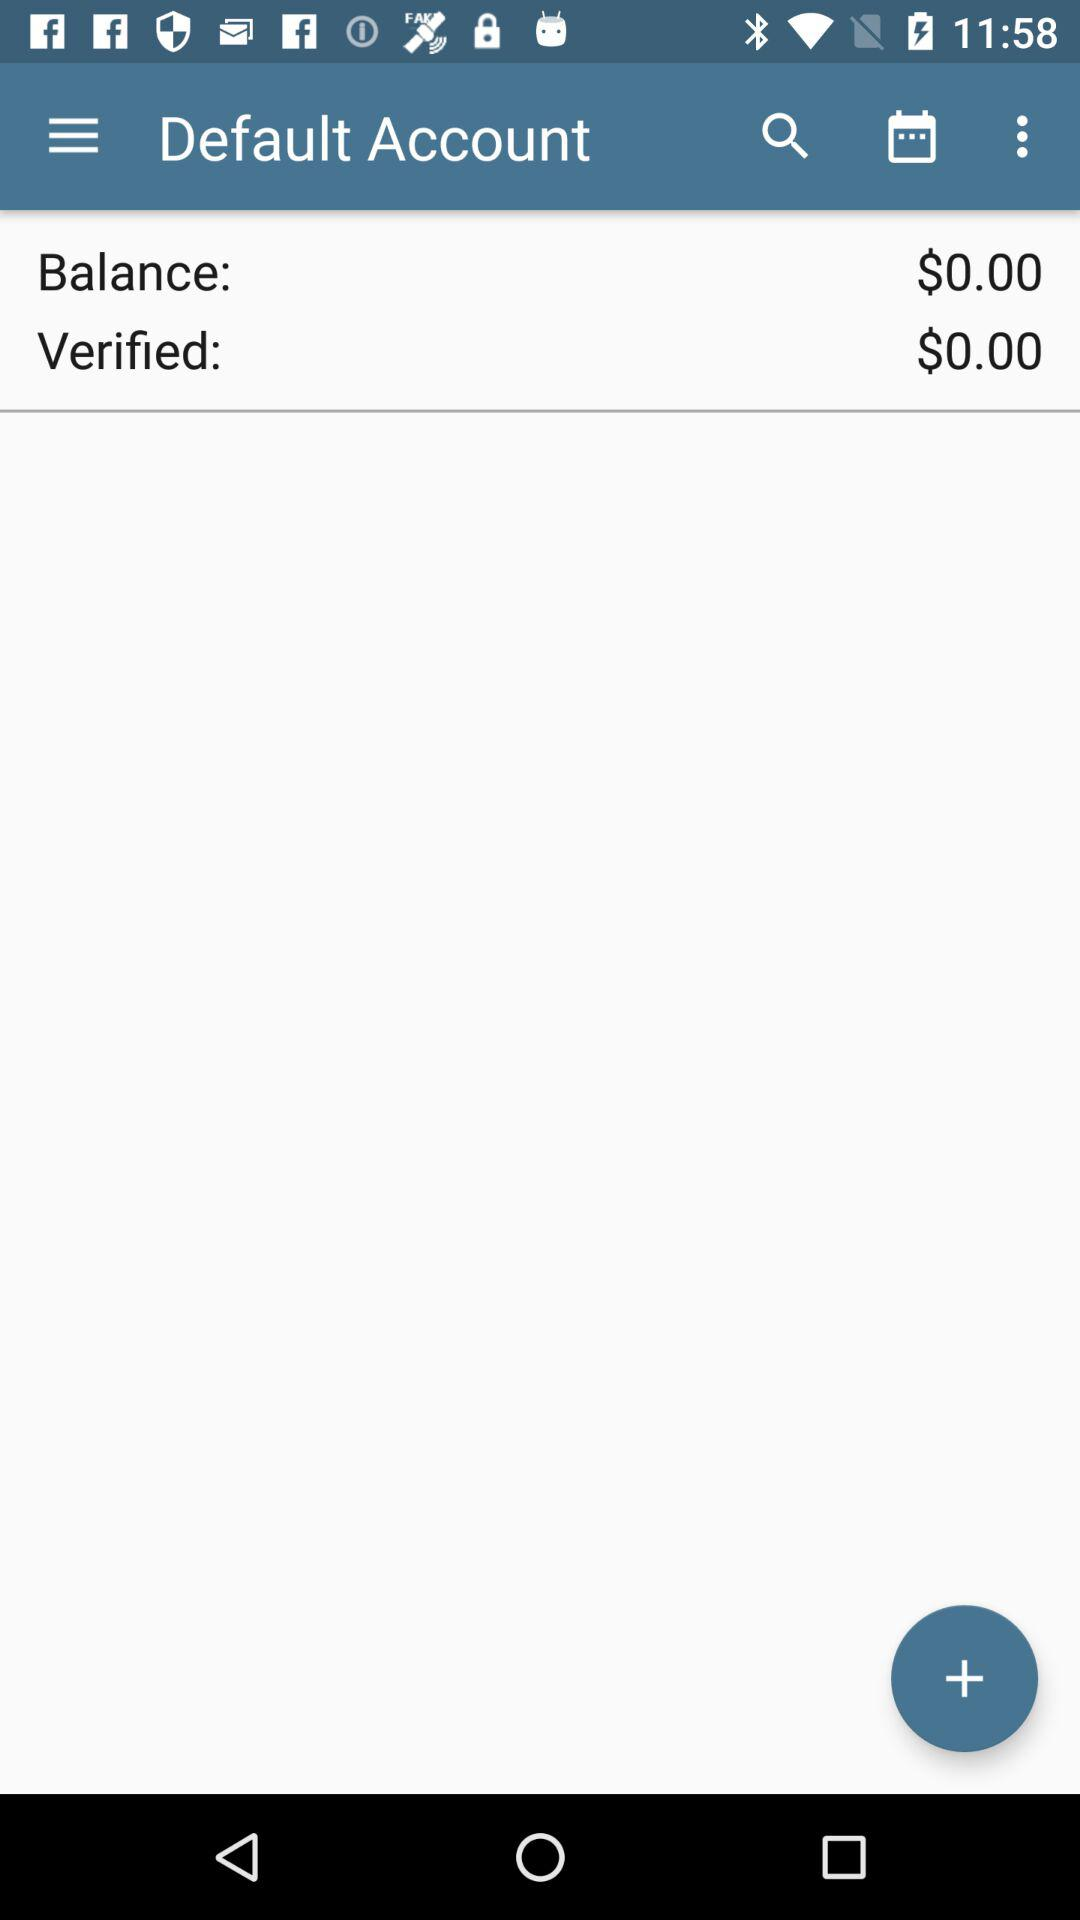How much is the balance in the account? The balance in the account is $0. 